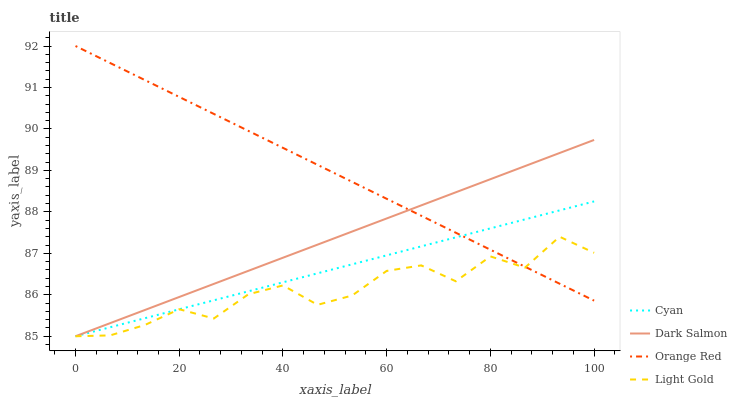Does Light Gold have the minimum area under the curve?
Answer yes or no. Yes. Does Orange Red have the maximum area under the curve?
Answer yes or no. Yes. Does Dark Salmon have the minimum area under the curve?
Answer yes or no. No. Does Dark Salmon have the maximum area under the curve?
Answer yes or no. No. Is Cyan the smoothest?
Answer yes or no. Yes. Is Light Gold the roughest?
Answer yes or no. Yes. Is Dark Salmon the smoothest?
Answer yes or no. No. Is Dark Salmon the roughest?
Answer yes or no. No. Does Cyan have the lowest value?
Answer yes or no. Yes. Does Orange Red have the lowest value?
Answer yes or no. No. Does Orange Red have the highest value?
Answer yes or no. Yes. Does Dark Salmon have the highest value?
Answer yes or no. No. Does Light Gold intersect Cyan?
Answer yes or no. Yes. Is Light Gold less than Cyan?
Answer yes or no. No. Is Light Gold greater than Cyan?
Answer yes or no. No. 